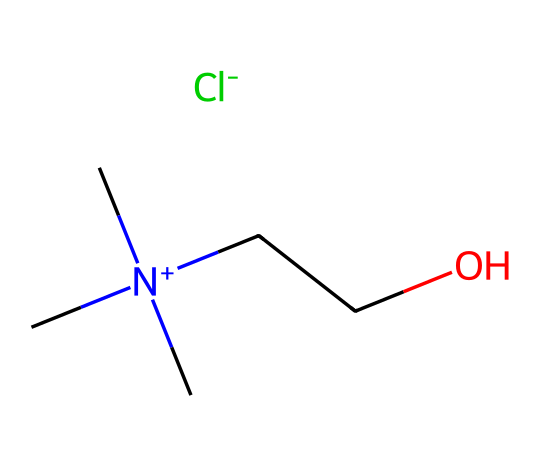How many carbon atoms are present in this ionic liquid? By examining the provided SMILES representation, the notation 'C' indicates carbon atoms. Counting each 'C' (there are four instances) and considering the one in the nitrogen cation further, we determine the total number of carbon atoms.
Answer: four What is the specific anion associated with this ionic liquid? Analyzing the SMILES, the '[Cl-]' segment at the end denotes the chloride ion, which acts as the anion in this ionic liquid structure.
Answer: chloride How many heteroatoms are present in this molecule? The molecule exhibits heteroatoms such as nitrogen (N) and oxygen (O). Counting these, we find one nitrogen atom and one oxygen atom contributes to the total.
Answer: two What role does choline play in this ionic liquid's structure? Choline, represented by the quaternary ammonium ion (C[N+](C)(C)), serves as a cation due to its positive charge and steric structure, which impacts the overall properties of the ionic liquid.
Answer: cation Does this ionic liquid have a symmetrical structure? Considering the cation's structure, the nitrogen atom is attached to three identical methyl groups and a hydroxyethyl group, indicating a certain level of symmetry at the cation site.
Answer: yes What advantages do choline-based ionic liquids offer in biosensor applications? Choline-based ionic liquids provide characteristics such as low volatility, high thermal stability, and the ability to solubilize biomolecules, making them suitable for improving biosensor performance.
Answer: improved biosensor performance Which type of bonds are primarily responsible for the interactions in this ionic liquid? Ionic interactions dominate due to the presence of a positively charged choline cation and the negatively charged chloride anion, allowing for solvation in biosensor contexts.
Answer: ionic interactions 